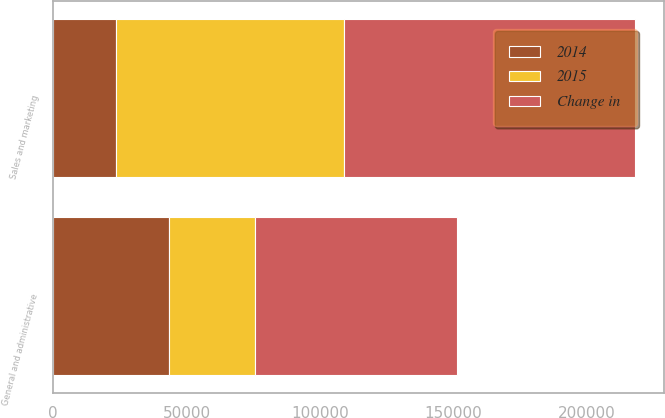<chart> <loc_0><loc_0><loc_500><loc_500><stacked_bar_chart><ecel><fcel>Sales and marketing<fcel>General and administrative<nl><fcel>Change in<fcel>109084<fcel>75720<nl><fcel>2015<fcel>85338<fcel>32331<nl><fcel>2014<fcel>23746<fcel>43389<nl></chart> 